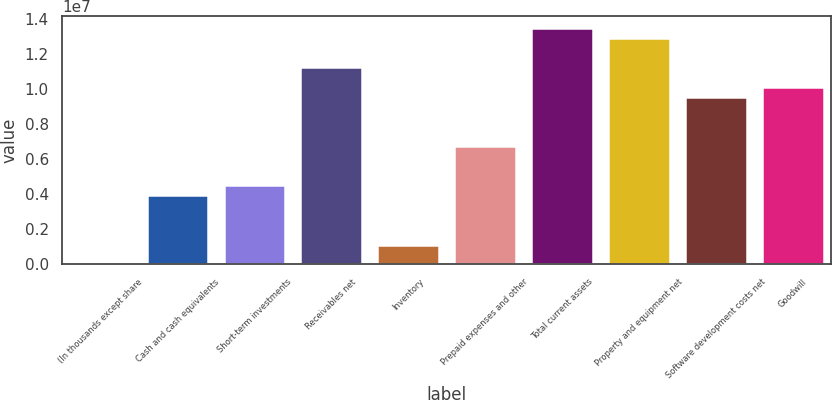Convert chart to OTSL. <chart><loc_0><loc_0><loc_500><loc_500><bar_chart><fcel>(In thousands except share<fcel>Cash and cash equivalents<fcel>Short-term investments<fcel>Receivables net<fcel>Inventory<fcel>Prepaid expenses and other<fcel>Total current assets<fcel>Property and equipment net<fcel>Software development costs net<fcel>Goodwill<nl><fcel>2016<fcel>3.94158e+06<fcel>4.50437e+06<fcel>1.12579e+07<fcel>1.12761e+06<fcel>6.75555e+06<fcel>1.35091e+07<fcel>1.29463e+07<fcel>9.56953e+06<fcel>1.01323e+07<nl></chart> 